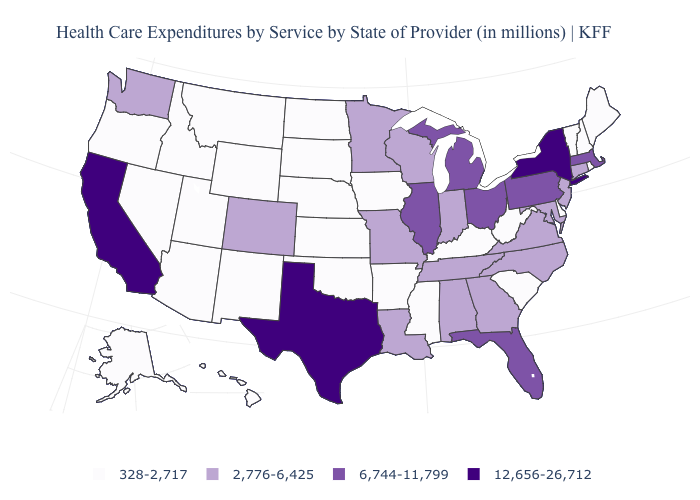Name the states that have a value in the range 328-2,717?
Quick response, please. Alaska, Arizona, Arkansas, Delaware, Hawaii, Idaho, Iowa, Kansas, Kentucky, Maine, Mississippi, Montana, Nebraska, Nevada, New Hampshire, New Mexico, North Dakota, Oklahoma, Oregon, Rhode Island, South Carolina, South Dakota, Utah, Vermont, West Virginia, Wyoming. Name the states that have a value in the range 2,776-6,425?
Give a very brief answer. Alabama, Colorado, Connecticut, Georgia, Indiana, Louisiana, Maryland, Minnesota, Missouri, New Jersey, North Carolina, Tennessee, Virginia, Washington, Wisconsin. What is the value of Oregon?
Short answer required. 328-2,717. Does Iowa have a lower value than North Carolina?
Concise answer only. Yes. What is the highest value in the MidWest ?
Give a very brief answer. 6,744-11,799. Among the states that border New York , does Vermont have the lowest value?
Give a very brief answer. Yes. Name the states that have a value in the range 328-2,717?
Concise answer only. Alaska, Arizona, Arkansas, Delaware, Hawaii, Idaho, Iowa, Kansas, Kentucky, Maine, Mississippi, Montana, Nebraska, Nevada, New Hampshire, New Mexico, North Dakota, Oklahoma, Oregon, Rhode Island, South Carolina, South Dakota, Utah, Vermont, West Virginia, Wyoming. Does the map have missing data?
Concise answer only. No. What is the value of Massachusetts?
Answer briefly. 6,744-11,799. What is the value of Texas?
Concise answer only. 12,656-26,712. Does West Virginia have a higher value than New Hampshire?
Quick response, please. No. Does the first symbol in the legend represent the smallest category?
Give a very brief answer. Yes. Name the states that have a value in the range 328-2,717?
Quick response, please. Alaska, Arizona, Arkansas, Delaware, Hawaii, Idaho, Iowa, Kansas, Kentucky, Maine, Mississippi, Montana, Nebraska, Nevada, New Hampshire, New Mexico, North Dakota, Oklahoma, Oregon, Rhode Island, South Carolina, South Dakota, Utah, Vermont, West Virginia, Wyoming. Does New York have the highest value in the USA?
Short answer required. Yes. Name the states that have a value in the range 2,776-6,425?
Write a very short answer. Alabama, Colorado, Connecticut, Georgia, Indiana, Louisiana, Maryland, Minnesota, Missouri, New Jersey, North Carolina, Tennessee, Virginia, Washington, Wisconsin. 